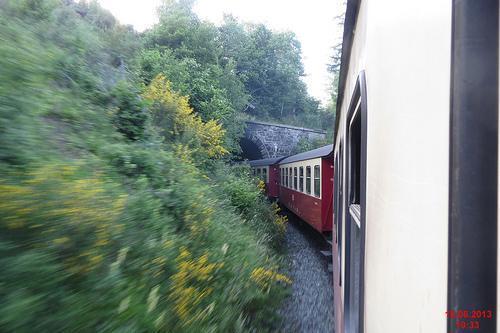How many red train carts can you see?
Give a very brief answer. 2. 